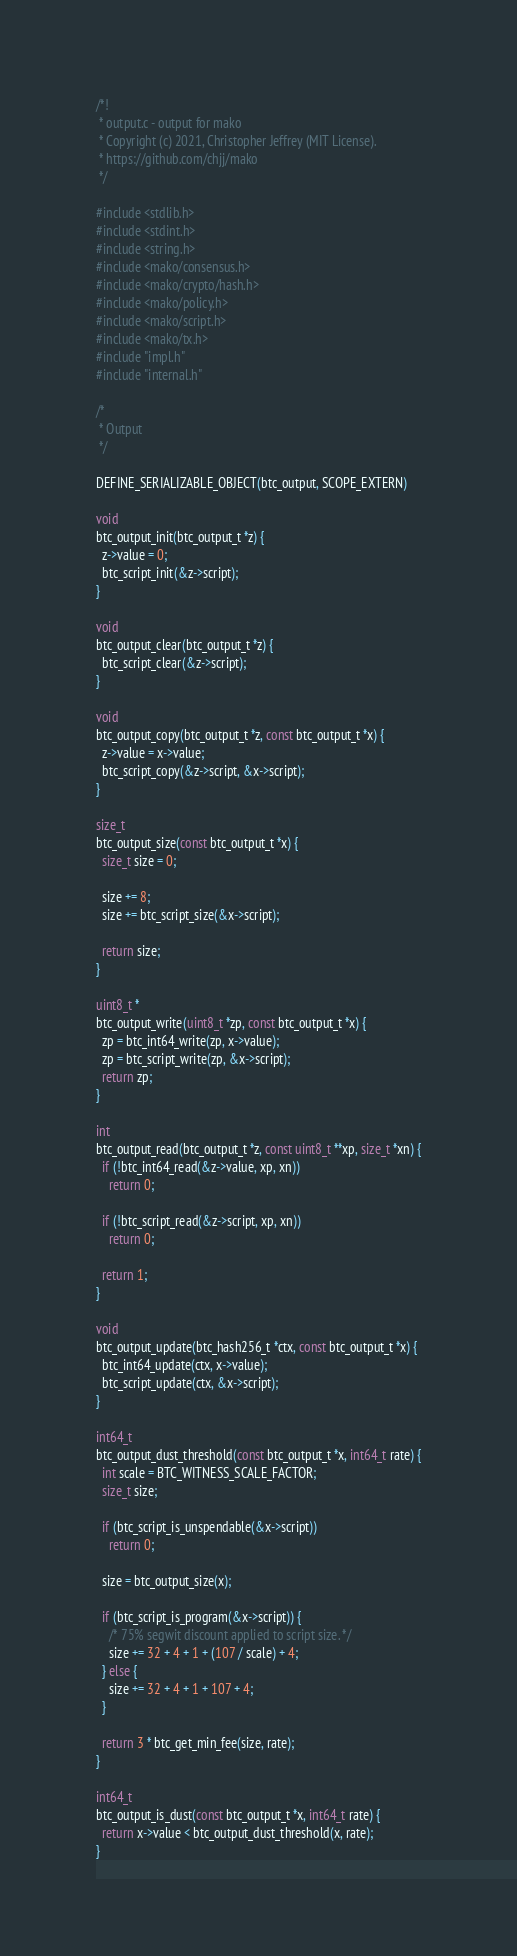<code> <loc_0><loc_0><loc_500><loc_500><_C_>/*!
 * output.c - output for mako
 * Copyright (c) 2021, Christopher Jeffrey (MIT License).
 * https://github.com/chjj/mako
 */

#include <stdlib.h>
#include <stdint.h>
#include <string.h>
#include <mako/consensus.h>
#include <mako/crypto/hash.h>
#include <mako/policy.h>
#include <mako/script.h>
#include <mako/tx.h>
#include "impl.h"
#include "internal.h"

/*
 * Output
 */

DEFINE_SERIALIZABLE_OBJECT(btc_output, SCOPE_EXTERN)

void
btc_output_init(btc_output_t *z) {
  z->value = 0;
  btc_script_init(&z->script);
}

void
btc_output_clear(btc_output_t *z) {
  btc_script_clear(&z->script);
}

void
btc_output_copy(btc_output_t *z, const btc_output_t *x) {
  z->value = x->value;
  btc_script_copy(&z->script, &x->script);
}

size_t
btc_output_size(const btc_output_t *x) {
  size_t size = 0;

  size += 8;
  size += btc_script_size(&x->script);

  return size;
}

uint8_t *
btc_output_write(uint8_t *zp, const btc_output_t *x) {
  zp = btc_int64_write(zp, x->value);
  zp = btc_script_write(zp, &x->script);
  return zp;
}

int
btc_output_read(btc_output_t *z, const uint8_t **xp, size_t *xn) {
  if (!btc_int64_read(&z->value, xp, xn))
    return 0;

  if (!btc_script_read(&z->script, xp, xn))
    return 0;

  return 1;
}

void
btc_output_update(btc_hash256_t *ctx, const btc_output_t *x) {
  btc_int64_update(ctx, x->value);
  btc_script_update(ctx, &x->script);
}

int64_t
btc_output_dust_threshold(const btc_output_t *x, int64_t rate) {
  int scale = BTC_WITNESS_SCALE_FACTOR;
  size_t size;

  if (btc_script_is_unspendable(&x->script))
    return 0;

  size = btc_output_size(x);

  if (btc_script_is_program(&x->script)) {
    /* 75% segwit discount applied to script size. */
    size += 32 + 4 + 1 + (107 / scale) + 4;
  } else {
    size += 32 + 4 + 1 + 107 + 4;
  }

  return 3 * btc_get_min_fee(size, rate);
}

int64_t
btc_output_is_dust(const btc_output_t *x, int64_t rate) {
  return x->value < btc_output_dust_threshold(x, rate);
}
</code> 